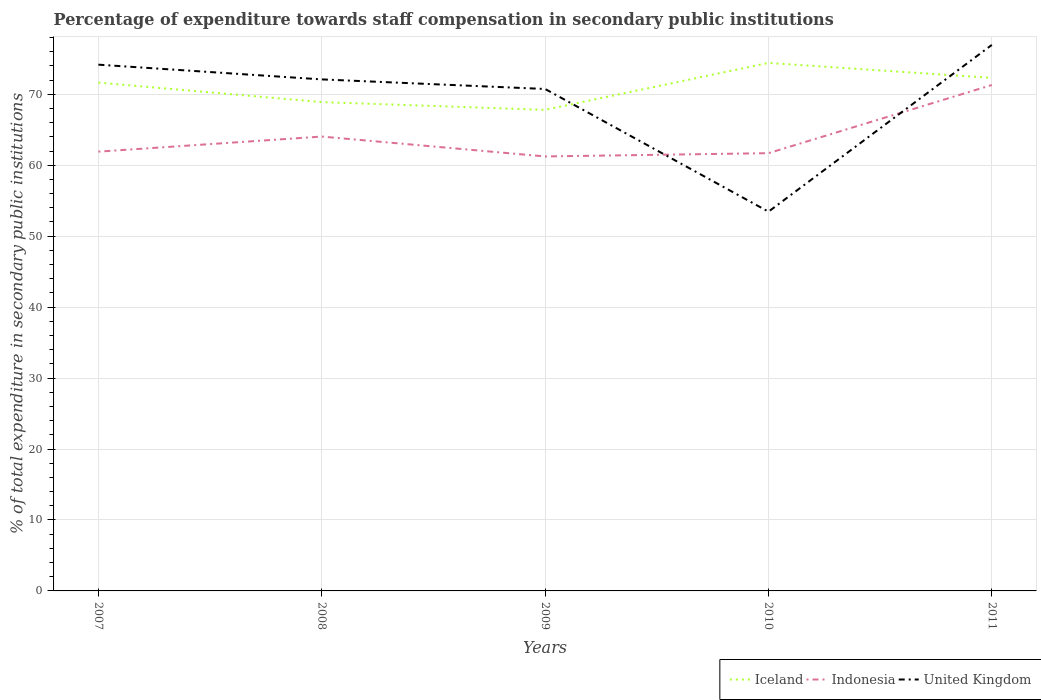How many different coloured lines are there?
Your answer should be very brief. 3. Does the line corresponding to Indonesia intersect with the line corresponding to Iceland?
Make the answer very short. No. Is the number of lines equal to the number of legend labels?
Your answer should be very brief. Yes. Across all years, what is the maximum percentage of expenditure towards staff compensation in Iceland?
Your answer should be very brief. 67.81. What is the total percentage of expenditure towards staff compensation in United Kingdom in the graph?
Your answer should be compact. -4.86. What is the difference between the highest and the second highest percentage of expenditure towards staff compensation in Indonesia?
Offer a very short reply. 10.07. Is the percentage of expenditure towards staff compensation in Iceland strictly greater than the percentage of expenditure towards staff compensation in Indonesia over the years?
Offer a terse response. No. How many years are there in the graph?
Provide a short and direct response. 5. What is the difference between two consecutive major ticks on the Y-axis?
Provide a succinct answer. 10. Are the values on the major ticks of Y-axis written in scientific E-notation?
Ensure brevity in your answer.  No. Does the graph contain grids?
Your answer should be compact. Yes. Where does the legend appear in the graph?
Offer a terse response. Bottom right. How many legend labels are there?
Your answer should be compact. 3. What is the title of the graph?
Provide a short and direct response. Percentage of expenditure towards staff compensation in secondary public institutions. What is the label or title of the Y-axis?
Offer a very short reply. % of total expenditure in secondary public institutions. What is the % of total expenditure in secondary public institutions of Iceland in 2007?
Offer a terse response. 71.65. What is the % of total expenditure in secondary public institutions of Indonesia in 2007?
Offer a terse response. 61.92. What is the % of total expenditure in secondary public institutions of United Kingdom in 2007?
Your response must be concise. 74.18. What is the % of total expenditure in secondary public institutions in Iceland in 2008?
Offer a terse response. 68.9. What is the % of total expenditure in secondary public institutions in Indonesia in 2008?
Provide a succinct answer. 64.04. What is the % of total expenditure in secondary public institutions of United Kingdom in 2008?
Ensure brevity in your answer.  72.1. What is the % of total expenditure in secondary public institutions in Iceland in 2009?
Keep it short and to the point. 67.81. What is the % of total expenditure in secondary public institutions in Indonesia in 2009?
Give a very brief answer. 61.24. What is the % of total expenditure in secondary public institutions of United Kingdom in 2009?
Provide a short and direct response. 70.75. What is the % of total expenditure in secondary public institutions in Iceland in 2010?
Give a very brief answer. 74.42. What is the % of total expenditure in secondary public institutions of Indonesia in 2010?
Ensure brevity in your answer.  61.7. What is the % of total expenditure in secondary public institutions of United Kingdom in 2010?
Offer a terse response. 53.46. What is the % of total expenditure in secondary public institutions in Iceland in 2011?
Keep it short and to the point. 72.31. What is the % of total expenditure in secondary public institutions of Indonesia in 2011?
Keep it short and to the point. 71.31. What is the % of total expenditure in secondary public institutions in United Kingdom in 2011?
Provide a short and direct response. 76.96. Across all years, what is the maximum % of total expenditure in secondary public institutions of Iceland?
Keep it short and to the point. 74.42. Across all years, what is the maximum % of total expenditure in secondary public institutions in Indonesia?
Provide a short and direct response. 71.31. Across all years, what is the maximum % of total expenditure in secondary public institutions in United Kingdom?
Offer a very short reply. 76.96. Across all years, what is the minimum % of total expenditure in secondary public institutions of Iceland?
Ensure brevity in your answer.  67.81. Across all years, what is the minimum % of total expenditure in secondary public institutions of Indonesia?
Your answer should be very brief. 61.24. Across all years, what is the minimum % of total expenditure in secondary public institutions of United Kingdom?
Your answer should be compact. 53.46. What is the total % of total expenditure in secondary public institutions of Iceland in the graph?
Offer a very short reply. 355.09. What is the total % of total expenditure in secondary public institutions of Indonesia in the graph?
Offer a terse response. 320.21. What is the total % of total expenditure in secondary public institutions in United Kingdom in the graph?
Your answer should be very brief. 347.44. What is the difference between the % of total expenditure in secondary public institutions in Iceland in 2007 and that in 2008?
Give a very brief answer. 2.75. What is the difference between the % of total expenditure in secondary public institutions of Indonesia in 2007 and that in 2008?
Keep it short and to the point. -2.13. What is the difference between the % of total expenditure in secondary public institutions of United Kingdom in 2007 and that in 2008?
Make the answer very short. 2.08. What is the difference between the % of total expenditure in secondary public institutions of Iceland in 2007 and that in 2009?
Provide a succinct answer. 3.84. What is the difference between the % of total expenditure in secondary public institutions in Indonesia in 2007 and that in 2009?
Keep it short and to the point. 0.68. What is the difference between the % of total expenditure in secondary public institutions in United Kingdom in 2007 and that in 2009?
Provide a succinct answer. 3.43. What is the difference between the % of total expenditure in secondary public institutions in Iceland in 2007 and that in 2010?
Keep it short and to the point. -2.78. What is the difference between the % of total expenditure in secondary public institutions in Indonesia in 2007 and that in 2010?
Your answer should be compact. 0.21. What is the difference between the % of total expenditure in secondary public institutions of United Kingdom in 2007 and that in 2010?
Offer a very short reply. 20.72. What is the difference between the % of total expenditure in secondary public institutions of Iceland in 2007 and that in 2011?
Provide a short and direct response. -0.67. What is the difference between the % of total expenditure in secondary public institutions in Indonesia in 2007 and that in 2011?
Your answer should be very brief. -9.39. What is the difference between the % of total expenditure in secondary public institutions of United Kingdom in 2007 and that in 2011?
Your response must be concise. -2.79. What is the difference between the % of total expenditure in secondary public institutions in Iceland in 2008 and that in 2009?
Provide a succinct answer. 1.09. What is the difference between the % of total expenditure in secondary public institutions of Indonesia in 2008 and that in 2009?
Give a very brief answer. 2.8. What is the difference between the % of total expenditure in secondary public institutions of United Kingdom in 2008 and that in 2009?
Give a very brief answer. 1.35. What is the difference between the % of total expenditure in secondary public institutions of Iceland in 2008 and that in 2010?
Offer a very short reply. -5.52. What is the difference between the % of total expenditure in secondary public institutions in Indonesia in 2008 and that in 2010?
Provide a short and direct response. 2.34. What is the difference between the % of total expenditure in secondary public institutions in United Kingdom in 2008 and that in 2010?
Your response must be concise. 18.64. What is the difference between the % of total expenditure in secondary public institutions in Iceland in 2008 and that in 2011?
Offer a terse response. -3.41. What is the difference between the % of total expenditure in secondary public institutions in Indonesia in 2008 and that in 2011?
Provide a short and direct response. -7.26. What is the difference between the % of total expenditure in secondary public institutions in United Kingdom in 2008 and that in 2011?
Your answer should be very brief. -4.86. What is the difference between the % of total expenditure in secondary public institutions in Iceland in 2009 and that in 2010?
Give a very brief answer. -6.62. What is the difference between the % of total expenditure in secondary public institutions in Indonesia in 2009 and that in 2010?
Ensure brevity in your answer.  -0.46. What is the difference between the % of total expenditure in secondary public institutions in United Kingdom in 2009 and that in 2010?
Your response must be concise. 17.29. What is the difference between the % of total expenditure in secondary public institutions in Iceland in 2009 and that in 2011?
Make the answer very short. -4.51. What is the difference between the % of total expenditure in secondary public institutions of Indonesia in 2009 and that in 2011?
Give a very brief answer. -10.07. What is the difference between the % of total expenditure in secondary public institutions of United Kingdom in 2009 and that in 2011?
Offer a very short reply. -6.21. What is the difference between the % of total expenditure in secondary public institutions in Iceland in 2010 and that in 2011?
Offer a terse response. 2.11. What is the difference between the % of total expenditure in secondary public institutions of Indonesia in 2010 and that in 2011?
Offer a terse response. -9.61. What is the difference between the % of total expenditure in secondary public institutions of United Kingdom in 2010 and that in 2011?
Keep it short and to the point. -23.5. What is the difference between the % of total expenditure in secondary public institutions in Iceland in 2007 and the % of total expenditure in secondary public institutions in Indonesia in 2008?
Your answer should be compact. 7.6. What is the difference between the % of total expenditure in secondary public institutions in Iceland in 2007 and the % of total expenditure in secondary public institutions in United Kingdom in 2008?
Your answer should be compact. -0.45. What is the difference between the % of total expenditure in secondary public institutions of Indonesia in 2007 and the % of total expenditure in secondary public institutions of United Kingdom in 2008?
Your answer should be very brief. -10.18. What is the difference between the % of total expenditure in secondary public institutions in Iceland in 2007 and the % of total expenditure in secondary public institutions in Indonesia in 2009?
Offer a terse response. 10.41. What is the difference between the % of total expenditure in secondary public institutions in Iceland in 2007 and the % of total expenditure in secondary public institutions in United Kingdom in 2009?
Your answer should be compact. 0.9. What is the difference between the % of total expenditure in secondary public institutions in Indonesia in 2007 and the % of total expenditure in secondary public institutions in United Kingdom in 2009?
Keep it short and to the point. -8.83. What is the difference between the % of total expenditure in secondary public institutions of Iceland in 2007 and the % of total expenditure in secondary public institutions of Indonesia in 2010?
Make the answer very short. 9.95. What is the difference between the % of total expenditure in secondary public institutions of Iceland in 2007 and the % of total expenditure in secondary public institutions of United Kingdom in 2010?
Provide a short and direct response. 18.19. What is the difference between the % of total expenditure in secondary public institutions of Indonesia in 2007 and the % of total expenditure in secondary public institutions of United Kingdom in 2010?
Ensure brevity in your answer.  8.46. What is the difference between the % of total expenditure in secondary public institutions of Iceland in 2007 and the % of total expenditure in secondary public institutions of Indonesia in 2011?
Your answer should be compact. 0.34. What is the difference between the % of total expenditure in secondary public institutions of Iceland in 2007 and the % of total expenditure in secondary public institutions of United Kingdom in 2011?
Ensure brevity in your answer.  -5.31. What is the difference between the % of total expenditure in secondary public institutions of Indonesia in 2007 and the % of total expenditure in secondary public institutions of United Kingdom in 2011?
Your answer should be compact. -15.04. What is the difference between the % of total expenditure in secondary public institutions in Iceland in 2008 and the % of total expenditure in secondary public institutions in Indonesia in 2009?
Give a very brief answer. 7.66. What is the difference between the % of total expenditure in secondary public institutions in Iceland in 2008 and the % of total expenditure in secondary public institutions in United Kingdom in 2009?
Offer a terse response. -1.85. What is the difference between the % of total expenditure in secondary public institutions in Indonesia in 2008 and the % of total expenditure in secondary public institutions in United Kingdom in 2009?
Your response must be concise. -6.71. What is the difference between the % of total expenditure in secondary public institutions in Iceland in 2008 and the % of total expenditure in secondary public institutions in Indonesia in 2010?
Offer a terse response. 7.2. What is the difference between the % of total expenditure in secondary public institutions of Iceland in 2008 and the % of total expenditure in secondary public institutions of United Kingdom in 2010?
Ensure brevity in your answer.  15.44. What is the difference between the % of total expenditure in secondary public institutions in Indonesia in 2008 and the % of total expenditure in secondary public institutions in United Kingdom in 2010?
Give a very brief answer. 10.59. What is the difference between the % of total expenditure in secondary public institutions of Iceland in 2008 and the % of total expenditure in secondary public institutions of Indonesia in 2011?
Provide a short and direct response. -2.41. What is the difference between the % of total expenditure in secondary public institutions in Iceland in 2008 and the % of total expenditure in secondary public institutions in United Kingdom in 2011?
Provide a short and direct response. -8.06. What is the difference between the % of total expenditure in secondary public institutions in Indonesia in 2008 and the % of total expenditure in secondary public institutions in United Kingdom in 2011?
Your answer should be compact. -12.92. What is the difference between the % of total expenditure in secondary public institutions in Iceland in 2009 and the % of total expenditure in secondary public institutions in Indonesia in 2010?
Make the answer very short. 6.11. What is the difference between the % of total expenditure in secondary public institutions in Iceland in 2009 and the % of total expenditure in secondary public institutions in United Kingdom in 2010?
Your answer should be very brief. 14.35. What is the difference between the % of total expenditure in secondary public institutions of Indonesia in 2009 and the % of total expenditure in secondary public institutions of United Kingdom in 2010?
Ensure brevity in your answer.  7.78. What is the difference between the % of total expenditure in secondary public institutions of Iceland in 2009 and the % of total expenditure in secondary public institutions of Indonesia in 2011?
Offer a terse response. -3.5. What is the difference between the % of total expenditure in secondary public institutions of Iceland in 2009 and the % of total expenditure in secondary public institutions of United Kingdom in 2011?
Offer a very short reply. -9.15. What is the difference between the % of total expenditure in secondary public institutions in Indonesia in 2009 and the % of total expenditure in secondary public institutions in United Kingdom in 2011?
Offer a terse response. -15.72. What is the difference between the % of total expenditure in secondary public institutions in Iceland in 2010 and the % of total expenditure in secondary public institutions in Indonesia in 2011?
Ensure brevity in your answer.  3.11. What is the difference between the % of total expenditure in secondary public institutions of Iceland in 2010 and the % of total expenditure in secondary public institutions of United Kingdom in 2011?
Ensure brevity in your answer.  -2.54. What is the difference between the % of total expenditure in secondary public institutions of Indonesia in 2010 and the % of total expenditure in secondary public institutions of United Kingdom in 2011?
Offer a terse response. -15.26. What is the average % of total expenditure in secondary public institutions of Iceland per year?
Provide a succinct answer. 71.02. What is the average % of total expenditure in secondary public institutions of Indonesia per year?
Provide a succinct answer. 64.04. What is the average % of total expenditure in secondary public institutions in United Kingdom per year?
Make the answer very short. 69.49. In the year 2007, what is the difference between the % of total expenditure in secondary public institutions in Iceland and % of total expenditure in secondary public institutions in Indonesia?
Provide a short and direct response. 9.73. In the year 2007, what is the difference between the % of total expenditure in secondary public institutions in Iceland and % of total expenditure in secondary public institutions in United Kingdom?
Keep it short and to the point. -2.53. In the year 2007, what is the difference between the % of total expenditure in secondary public institutions in Indonesia and % of total expenditure in secondary public institutions in United Kingdom?
Offer a terse response. -12.26. In the year 2008, what is the difference between the % of total expenditure in secondary public institutions of Iceland and % of total expenditure in secondary public institutions of Indonesia?
Provide a succinct answer. 4.86. In the year 2008, what is the difference between the % of total expenditure in secondary public institutions in Iceland and % of total expenditure in secondary public institutions in United Kingdom?
Make the answer very short. -3.2. In the year 2008, what is the difference between the % of total expenditure in secondary public institutions of Indonesia and % of total expenditure in secondary public institutions of United Kingdom?
Ensure brevity in your answer.  -8.06. In the year 2009, what is the difference between the % of total expenditure in secondary public institutions of Iceland and % of total expenditure in secondary public institutions of Indonesia?
Provide a succinct answer. 6.57. In the year 2009, what is the difference between the % of total expenditure in secondary public institutions in Iceland and % of total expenditure in secondary public institutions in United Kingdom?
Your answer should be compact. -2.94. In the year 2009, what is the difference between the % of total expenditure in secondary public institutions of Indonesia and % of total expenditure in secondary public institutions of United Kingdom?
Provide a short and direct response. -9.51. In the year 2010, what is the difference between the % of total expenditure in secondary public institutions of Iceland and % of total expenditure in secondary public institutions of Indonesia?
Offer a very short reply. 12.72. In the year 2010, what is the difference between the % of total expenditure in secondary public institutions of Iceland and % of total expenditure in secondary public institutions of United Kingdom?
Ensure brevity in your answer.  20.97. In the year 2010, what is the difference between the % of total expenditure in secondary public institutions in Indonesia and % of total expenditure in secondary public institutions in United Kingdom?
Keep it short and to the point. 8.24. In the year 2011, what is the difference between the % of total expenditure in secondary public institutions of Iceland and % of total expenditure in secondary public institutions of Indonesia?
Offer a terse response. 1. In the year 2011, what is the difference between the % of total expenditure in secondary public institutions in Iceland and % of total expenditure in secondary public institutions in United Kingdom?
Ensure brevity in your answer.  -4.65. In the year 2011, what is the difference between the % of total expenditure in secondary public institutions in Indonesia and % of total expenditure in secondary public institutions in United Kingdom?
Give a very brief answer. -5.65. What is the ratio of the % of total expenditure in secondary public institutions in Iceland in 2007 to that in 2008?
Provide a short and direct response. 1.04. What is the ratio of the % of total expenditure in secondary public institutions of Indonesia in 2007 to that in 2008?
Your answer should be compact. 0.97. What is the ratio of the % of total expenditure in secondary public institutions of United Kingdom in 2007 to that in 2008?
Ensure brevity in your answer.  1.03. What is the ratio of the % of total expenditure in secondary public institutions in Iceland in 2007 to that in 2009?
Offer a terse response. 1.06. What is the ratio of the % of total expenditure in secondary public institutions of Indonesia in 2007 to that in 2009?
Make the answer very short. 1.01. What is the ratio of the % of total expenditure in secondary public institutions of United Kingdom in 2007 to that in 2009?
Offer a terse response. 1.05. What is the ratio of the % of total expenditure in secondary public institutions in Iceland in 2007 to that in 2010?
Ensure brevity in your answer.  0.96. What is the ratio of the % of total expenditure in secondary public institutions in Indonesia in 2007 to that in 2010?
Offer a terse response. 1. What is the ratio of the % of total expenditure in secondary public institutions of United Kingdom in 2007 to that in 2010?
Your response must be concise. 1.39. What is the ratio of the % of total expenditure in secondary public institutions in Iceland in 2007 to that in 2011?
Ensure brevity in your answer.  0.99. What is the ratio of the % of total expenditure in secondary public institutions of Indonesia in 2007 to that in 2011?
Ensure brevity in your answer.  0.87. What is the ratio of the % of total expenditure in secondary public institutions of United Kingdom in 2007 to that in 2011?
Provide a succinct answer. 0.96. What is the ratio of the % of total expenditure in secondary public institutions in Iceland in 2008 to that in 2009?
Provide a succinct answer. 1.02. What is the ratio of the % of total expenditure in secondary public institutions of Indonesia in 2008 to that in 2009?
Give a very brief answer. 1.05. What is the ratio of the % of total expenditure in secondary public institutions of United Kingdom in 2008 to that in 2009?
Your answer should be very brief. 1.02. What is the ratio of the % of total expenditure in secondary public institutions in Iceland in 2008 to that in 2010?
Your answer should be very brief. 0.93. What is the ratio of the % of total expenditure in secondary public institutions of Indonesia in 2008 to that in 2010?
Your answer should be compact. 1.04. What is the ratio of the % of total expenditure in secondary public institutions in United Kingdom in 2008 to that in 2010?
Your answer should be compact. 1.35. What is the ratio of the % of total expenditure in secondary public institutions in Iceland in 2008 to that in 2011?
Provide a short and direct response. 0.95. What is the ratio of the % of total expenditure in secondary public institutions of Indonesia in 2008 to that in 2011?
Offer a very short reply. 0.9. What is the ratio of the % of total expenditure in secondary public institutions in United Kingdom in 2008 to that in 2011?
Your answer should be very brief. 0.94. What is the ratio of the % of total expenditure in secondary public institutions in Iceland in 2009 to that in 2010?
Give a very brief answer. 0.91. What is the ratio of the % of total expenditure in secondary public institutions in Indonesia in 2009 to that in 2010?
Offer a very short reply. 0.99. What is the ratio of the % of total expenditure in secondary public institutions of United Kingdom in 2009 to that in 2010?
Ensure brevity in your answer.  1.32. What is the ratio of the % of total expenditure in secondary public institutions of Iceland in 2009 to that in 2011?
Your answer should be very brief. 0.94. What is the ratio of the % of total expenditure in secondary public institutions in Indonesia in 2009 to that in 2011?
Give a very brief answer. 0.86. What is the ratio of the % of total expenditure in secondary public institutions of United Kingdom in 2009 to that in 2011?
Ensure brevity in your answer.  0.92. What is the ratio of the % of total expenditure in secondary public institutions of Iceland in 2010 to that in 2011?
Offer a terse response. 1.03. What is the ratio of the % of total expenditure in secondary public institutions in Indonesia in 2010 to that in 2011?
Give a very brief answer. 0.87. What is the ratio of the % of total expenditure in secondary public institutions in United Kingdom in 2010 to that in 2011?
Make the answer very short. 0.69. What is the difference between the highest and the second highest % of total expenditure in secondary public institutions in Iceland?
Offer a terse response. 2.11. What is the difference between the highest and the second highest % of total expenditure in secondary public institutions of Indonesia?
Provide a short and direct response. 7.26. What is the difference between the highest and the second highest % of total expenditure in secondary public institutions in United Kingdom?
Ensure brevity in your answer.  2.79. What is the difference between the highest and the lowest % of total expenditure in secondary public institutions in Iceland?
Ensure brevity in your answer.  6.62. What is the difference between the highest and the lowest % of total expenditure in secondary public institutions in Indonesia?
Provide a succinct answer. 10.07. What is the difference between the highest and the lowest % of total expenditure in secondary public institutions in United Kingdom?
Give a very brief answer. 23.5. 